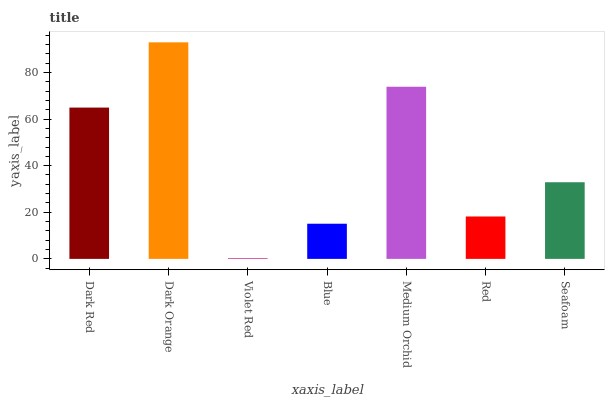Is Dark Orange the minimum?
Answer yes or no. No. Is Violet Red the maximum?
Answer yes or no. No. Is Dark Orange greater than Violet Red?
Answer yes or no. Yes. Is Violet Red less than Dark Orange?
Answer yes or no. Yes. Is Violet Red greater than Dark Orange?
Answer yes or no. No. Is Dark Orange less than Violet Red?
Answer yes or no. No. Is Seafoam the high median?
Answer yes or no. Yes. Is Seafoam the low median?
Answer yes or no. Yes. Is Red the high median?
Answer yes or no. No. Is Medium Orchid the low median?
Answer yes or no. No. 